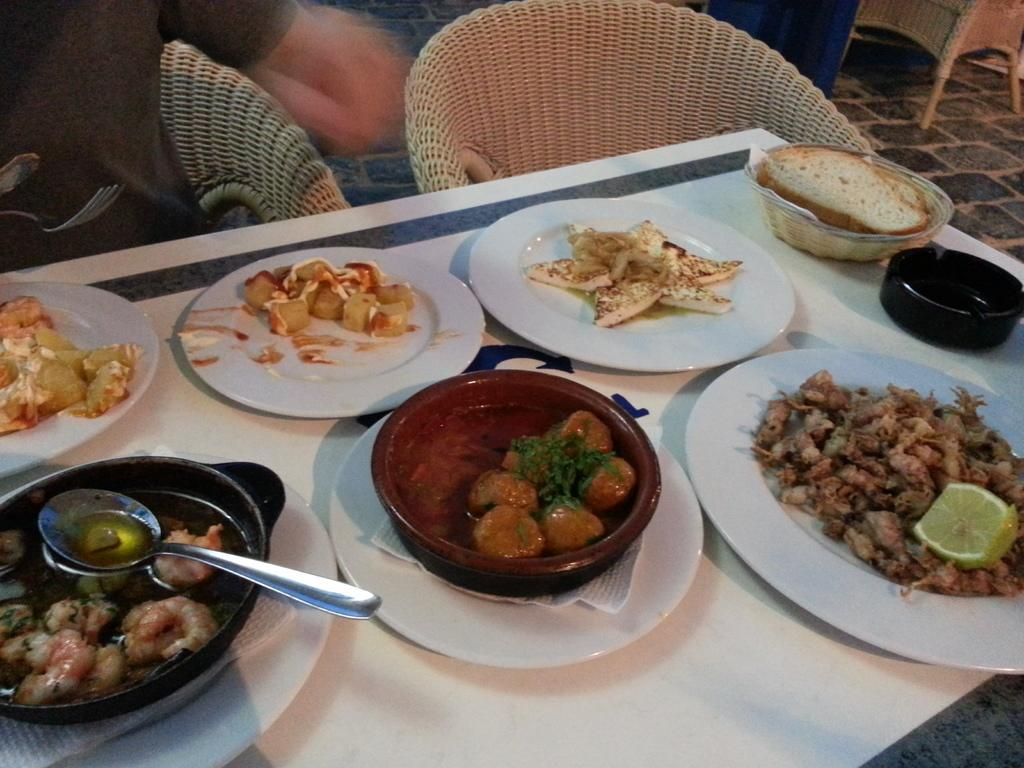What is located at the bottom of the image? There is a table at the bottom of the image. What objects are on the table? There are plates, bowls, spoons, and food on the table. What might be used for eating the food on the table? The spoons on the table might be used for eating the food. What is located behind the table? There are chairs behind the table. What type of wool is being used to make the scarf on the table? There is no scarf or wool present in the image. What color is the van parked next to the table? There is no van present in the image. 